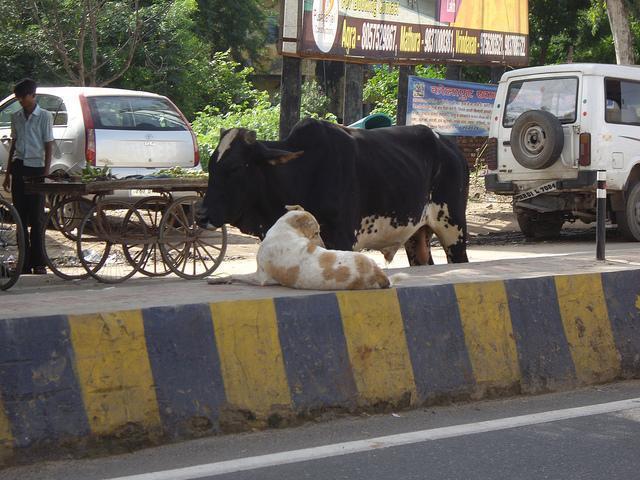What is known as the best cut of meat from the largest animal?
Indicate the correct response and explain using: 'Answer: answer
Rationale: rationale.'
Options: Chuck, sirloin, ribeye, filet mignon. Answer: filet mignon.
Rationale: That is the meat the bull is known to have when it's cut up. 